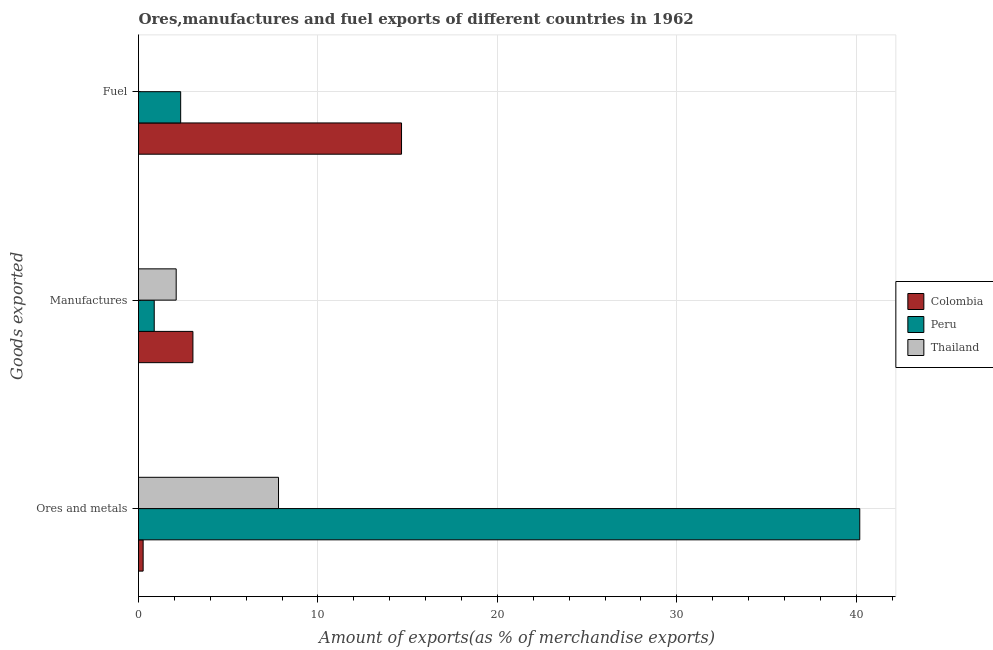Are the number of bars per tick equal to the number of legend labels?
Your response must be concise. Yes. Are the number of bars on each tick of the Y-axis equal?
Your answer should be very brief. Yes. How many bars are there on the 2nd tick from the top?
Your response must be concise. 3. How many bars are there on the 3rd tick from the bottom?
Offer a terse response. 3. What is the label of the 2nd group of bars from the top?
Your answer should be very brief. Manufactures. What is the percentage of manufactures exports in Colombia?
Keep it short and to the point. 3.03. Across all countries, what is the maximum percentage of ores and metals exports?
Give a very brief answer. 40.19. Across all countries, what is the minimum percentage of fuel exports?
Make the answer very short. 4.29334186834711e-5. In which country was the percentage of ores and metals exports maximum?
Provide a succinct answer. Peru. What is the total percentage of manufactures exports in the graph?
Your response must be concise. 6.01. What is the difference between the percentage of fuel exports in Peru and that in Colombia?
Keep it short and to the point. -12.31. What is the difference between the percentage of manufactures exports in Peru and the percentage of ores and metals exports in Thailand?
Provide a succinct answer. -6.93. What is the average percentage of ores and metals exports per country?
Your answer should be compact. 16.08. What is the difference between the percentage of fuel exports and percentage of manufactures exports in Peru?
Your answer should be very brief. 1.47. What is the ratio of the percentage of manufactures exports in Thailand to that in Colombia?
Provide a short and direct response. 0.69. Is the percentage of ores and metals exports in Thailand less than that in Peru?
Offer a terse response. Yes. What is the difference between the highest and the second highest percentage of ores and metals exports?
Offer a terse response. 32.39. What is the difference between the highest and the lowest percentage of manufactures exports?
Offer a very short reply. 2.16. Is the sum of the percentage of manufactures exports in Thailand and Colombia greater than the maximum percentage of ores and metals exports across all countries?
Give a very brief answer. No. What does the 1st bar from the top in Ores and metals represents?
Provide a short and direct response. Thailand. What does the 3rd bar from the bottom in Manufactures represents?
Provide a succinct answer. Thailand. Are the values on the major ticks of X-axis written in scientific E-notation?
Provide a succinct answer. No. Does the graph contain any zero values?
Offer a very short reply. No. Does the graph contain grids?
Provide a succinct answer. Yes. How many legend labels are there?
Ensure brevity in your answer.  3. What is the title of the graph?
Keep it short and to the point. Ores,manufactures and fuel exports of different countries in 1962. What is the label or title of the X-axis?
Provide a succinct answer. Amount of exports(as % of merchandise exports). What is the label or title of the Y-axis?
Your answer should be very brief. Goods exported. What is the Amount of exports(as % of merchandise exports) in Colombia in Ores and metals?
Provide a short and direct response. 0.26. What is the Amount of exports(as % of merchandise exports) in Peru in Ores and metals?
Ensure brevity in your answer.  40.19. What is the Amount of exports(as % of merchandise exports) in Thailand in Ores and metals?
Your answer should be compact. 7.8. What is the Amount of exports(as % of merchandise exports) in Colombia in Manufactures?
Your response must be concise. 3.03. What is the Amount of exports(as % of merchandise exports) in Peru in Manufactures?
Offer a terse response. 0.88. What is the Amount of exports(as % of merchandise exports) in Thailand in Manufactures?
Ensure brevity in your answer.  2.1. What is the Amount of exports(as % of merchandise exports) in Colombia in Fuel?
Offer a terse response. 14.66. What is the Amount of exports(as % of merchandise exports) in Peru in Fuel?
Offer a very short reply. 2.35. What is the Amount of exports(as % of merchandise exports) of Thailand in Fuel?
Give a very brief answer. 4.29334186834711e-5. Across all Goods exported, what is the maximum Amount of exports(as % of merchandise exports) in Colombia?
Your answer should be very brief. 14.66. Across all Goods exported, what is the maximum Amount of exports(as % of merchandise exports) of Peru?
Provide a succinct answer. 40.19. Across all Goods exported, what is the maximum Amount of exports(as % of merchandise exports) of Thailand?
Offer a terse response. 7.8. Across all Goods exported, what is the minimum Amount of exports(as % of merchandise exports) of Colombia?
Offer a very short reply. 0.26. Across all Goods exported, what is the minimum Amount of exports(as % of merchandise exports) in Peru?
Ensure brevity in your answer.  0.88. Across all Goods exported, what is the minimum Amount of exports(as % of merchandise exports) in Thailand?
Your response must be concise. 4.29334186834711e-5. What is the total Amount of exports(as % of merchandise exports) in Colombia in the graph?
Offer a very short reply. 17.95. What is the total Amount of exports(as % of merchandise exports) of Peru in the graph?
Offer a very short reply. 43.42. What is the total Amount of exports(as % of merchandise exports) in Thailand in the graph?
Provide a succinct answer. 9.9. What is the difference between the Amount of exports(as % of merchandise exports) of Colombia in Ores and metals and that in Manufactures?
Offer a terse response. -2.77. What is the difference between the Amount of exports(as % of merchandise exports) in Peru in Ores and metals and that in Manufactures?
Your response must be concise. 39.32. What is the difference between the Amount of exports(as % of merchandise exports) in Thailand in Ores and metals and that in Manufactures?
Provide a succinct answer. 5.7. What is the difference between the Amount of exports(as % of merchandise exports) in Colombia in Ores and metals and that in Fuel?
Ensure brevity in your answer.  -14.4. What is the difference between the Amount of exports(as % of merchandise exports) in Peru in Ores and metals and that in Fuel?
Your answer should be compact. 37.84. What is the difference between the Amount of exports(as % of merchandise exports) in Thailand in Ores and metals and that in Fuel?
Your answer should be compact. 7.8. What is the difference between the Amount of exports(as % of merchandise exports) in Colombia in Manufactures and that in Fuel?
Keep it short and to the point. -11.62. What is the difference between the Amount of exports(as % of merchandise exports) of Peru in Manufactures and that in Fuel?
Your answer should be very brief. -1.47. What is the difference between the Amount of exports(as % of merchandise exports) of Thailand in Manufactures and that in Fuel?
Provide a succinct answer. 2.1. What is the difference between the Amount of exports(as % of merchandise exports) in Colombia in Ores and metals and the Amount of exports(as % of merchandise exports) in Peru in Manufactures?
Your response must be concise. -0.62. What is the difference between the Amount of exports(as % of merchandise exports) of Colombia in Ores and metals and the Amount of exports(as % of merchandise exports) of Thailand in Manufactures?
Offer a terse response. -1.84. What is the difference between the Amount of exports(as % of merchandise exports) of Peru in Ores and metals and the Amount of exports(as % of merchandise exports) of Thailand in Manufactures?
Offer a very short reply. 38.09. What is the difference between the Amount of exports(as % of merchandise exports) of Colombia in Ores and metals and the Amount of exports(as % of merchandise exports) of Peru in Fuel?
Your response must be concise. -2.09. What is the difference between the Amount of exports(as % of merchandise exports) in Colombia in Ores and metals and the Amount of exports(as % of merchandise exports) in Thailand in Fuel?
Make the answer very short. 0.26. What is the difference between the Amount of exports(as % of merchandise exports) in Peru in Ores and metals and the Amount of exports(as % of merchandise exports) in Thailand in Fuel?
Provide a succinct answer. 40.19. What is the difference between the Amount of exports(as % of merchandise exports) in Colombia in Manufactures and the Amount of exports(as % of merchandise exports) in Peru in Fuel?
Make the answer very short. 0.68. What is the difference between the Amount of exports(as % of merchandise exports) in Colombia in Manufactures and the Amount of exports(as % of merchandise exports) in Thailand in Fuel?
Provide a short and direct response. 3.03. What is the difference between the Amount of exports(as % of merchandise exports) in Peru in Manufactures and the Amount of exports(as % of merchandise exports) in Thailand in Fuel?
Offer a very short reply. 0.88. What is the average Amount of exports(as % of merchandise exports) of Colombia per Goods exported?
Keep it short and to the point. 5.98. What is the average Amount of exports(as % of merchandise exports) in Peru per Goods exported?
Your response must be concise. 14.47. What is the average Amount of exports(as % of merchandise exports) in Thailand per Goods exported?
Keep it short and to the point. 3.3. What is the difference between the Amount of exports(as % of merchandise exports) of Colombia and Amount of exports(as % of merchandise exports) of Peru in Ores and metals?
Keep it short and to the point. -39.93. What is the difference between the Amount of exports(as % of merchandise exports) in Colombia and Amount of exports(as % of merchandise exports) in Thailand in Ores and metals?
Your answer should be very brief. -7.54. What is the difference between the Amount of exports(as % of merchandise exports) of Peru and Amount of exports(as % of merchandise exports) of Thailand in Ores and metals?
Your answer should be compact. 32.39. What is the difference between the Amount of exports(as % of merchandise exports) of Colombia and Amount of exports(as % of merchandise exports) of Peru in Manufactures?
Ensure brevity in your answer.  2.16. What is the difference between the Amount of exports(as % of merchandise exports) in Colombia and Amount of exports(as % of merchandise exports) in Thailand in Manufactures?
Provide a short and direct response. 0.93. What is the difference between the Amount of exports(as % of merchandise exports) of Peru and Amount of exports(as % of merchandise exports) of Thailand in Manufactures?
Give a very brief answer. -1.22. What is the difference between the Amount of exports(as % of merchandise exports) of Colombia and Amount of exports(as % of merchandise exports) of Peru in Fuel?
Ensure brevity in your answer.  12.31. What is the difference between the Amount of exports(as % of merchandise exports) of Colombia and Amount of exports(as % of merchandise exports) of Thailand in Fuel?
Keep it short and to the point. 14.66. What is the difference between the Amount of exports(as % of merchandise exports) in Peru and Amount of exports(as % of merchandise exports) in Thailand in Fuel?
Your response must be concise. 2.35. What is the ratio of the Amount of exports(as % of merchandise exports) in Colombia in Ores and metals to that in Manufactures?
Ensure brevity in your answer.  0.09. What is the ratio of the Amount of exports(as % of merchandise exports) in Peru in Ores and metals to that in Manufactures?
Provide a short and direct response. 45.87. What is the ratio of the Amount of exports(as % of merchandise exports) in Thailand in Ores and metals to that in Manufactures?
Your answer should be very brief. 3.72. What is the ratio of the Amount of exports(as % of merchandise exports) of Colombia in Ores and metals to that in Fuel?
Keep it short and to the point. 0.02. What is the ratio of the Amount of exports(as % of merchandise exports) in Peru in Ores and metals to that in Fuel?
Your answer should be compact. 17.1. What is the ratio of the Amount of exports(as % of merchandise exports) of Thailand in Ores and metals to that in Fuel?
Make the answer very short. 1.82e+05. What is the ratio of the Amount of exports(as % of merchandise exports) in Colombia in Manufactures to that in Fuel?
Give a very brief answer. 0.21. What is the ratio of the Amount of exports(as % of merchandise exports) in Peru in Manufactures to that in Fuel?
Provide a short and direct response. 0.37. What is the ratio of the Amount of exports(as % of merchandise exports) of Thailand in Manufactures to that in Fuel?
Provide a succinct answer. 4.89e+04. What is the difference between the highest and the second highest Amount of exports(as % of merchandise exports) of Colombia?
Offer a terse response. 11.62. What is the difference between the highest and the second highest Amount of exports(as % of merchandise exports) of Peru?
Offer a terse response. 37.84. What is the difference between the highest and the second highest Amount of exports(as % of merchandise exports) in Thailand?
Ensure brevity in your answer.  5.7. What is the difference between the highest and the lowest Amount of exports(as % of merchandise exports) of Colombia?
Ensure brevity in your answer.  14.4. What is the difference between the highest and the lowest Amount of exports(as % of merchandise exports) in Peru?
Make the answer very short. 39.32. What is the difference between the highest and the lowest Amount of exports(as % of merchandise exports) of Thailand?
Provide a short and direct response. 7.8. 